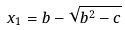Convert formula to latex. <formula><loc_0><loc_0><loc_500><loc_500>x _ { 1 } = b - \sqrt { b ^ { 2 } - c }</formula> 